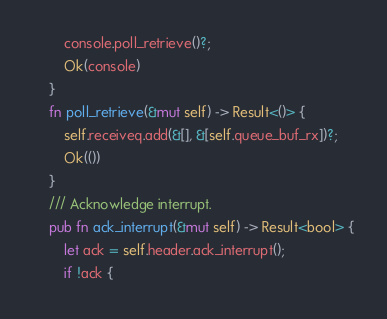Convert code to text. <code><loc_0><loc_0><loc_500><loc_500><_Rust_>        console.poll_retrieve()?;
        Ok(console)
    }
    fn poll_retrieve(&mut self) -> Result<()> {
        self.receiveq.add(&[], &[self.queue_buf_rx])?;
        Ok(())
    }
    /// Acknowledge interrupt.
    pub fn ack_interrupt(&mut self) -> Result<bool> {
        let ack = self.header.ack_interrupt();
        if !ack {</code> 